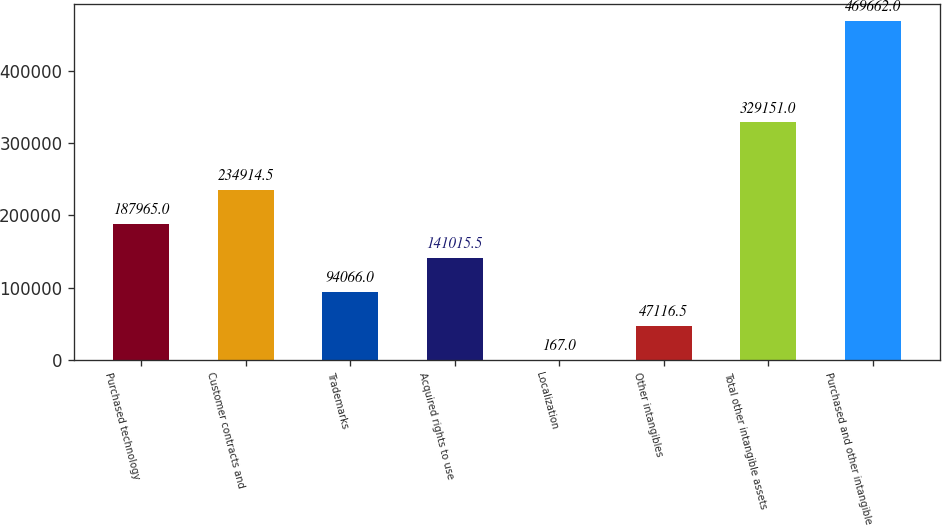<chart> <loc_0><loc_0><loc_500><loc_500><bar_chart><fcel>Purchased technology<fcel>Customer contracts and<fcel>Trademarks<fcel>Acquired rights to use<fcel>Localization<fcel>Other intangibles<fcel>Total other intangible assets<fcel>Purchased and other intangible<nl><fcel>187965<fcel>234914<fcel>94066<fcel>141016<fcel>167<fcel>47116.5<fcel>329151<fcel>469662<nl></chart> 